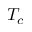Convert formula to latex. <formula><loc_0><loc_0><loc_500><loc_500>T _ { c }</formula> 